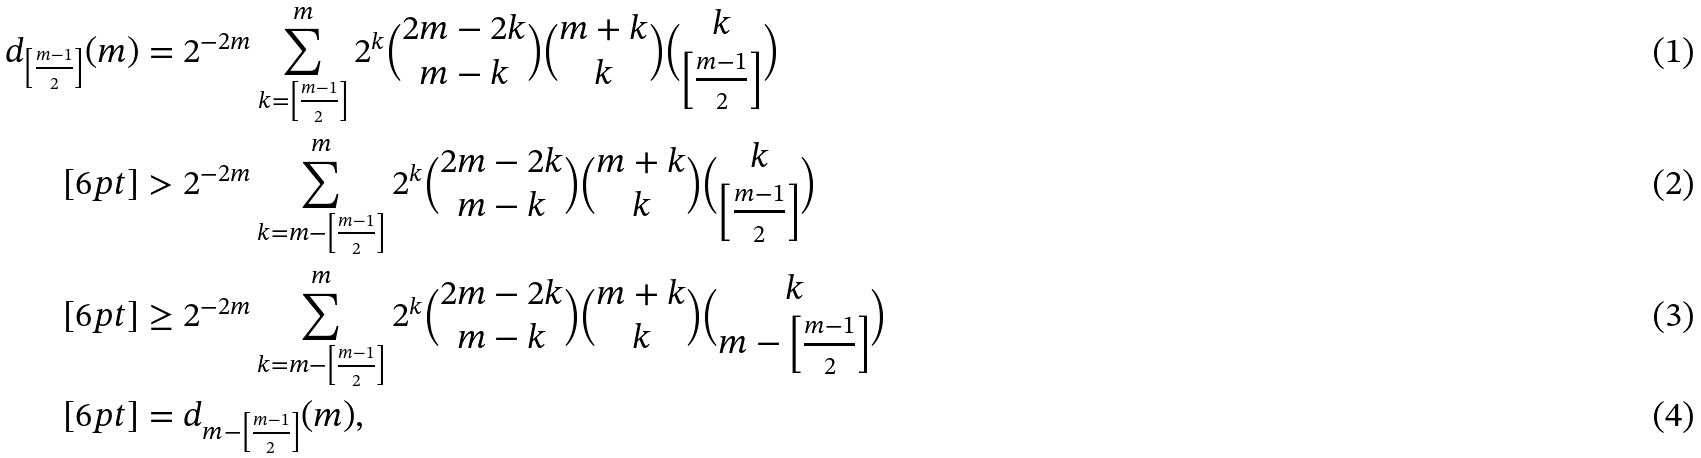<formula> <loc_0><loc_0><loc_500><loc_500>d _ { \left [ \frac { m - 1 } { 2 } \right ] } ( m ) & = 2 ^ { - 2 m } \sum _ { k = \left [ \frac { m - 1 } { 2 } \right ] } ^ { m } 2 ^ { k } { 2 m - 2 k \choose m - k } { m + k \choose k } { k \choose \left [ \frac { m - 1 } { 2 } \right ] } \\ [ 6 p t ] & > 2 ^ { - 2 m } \sum _ { k = m - \left [ \frac { m - 1 } { 2 } \right ] } ^ { m } 2 ^ { k } { 2 m - 2 k \choose m - k } { m + k \choose k } { k \choose \left [ \frac { m - 1 } { 2 } \right ] } \\ [ 6 p t ] & \geq 2 ^ { - 2 m } \sum _ { k = m - \left [ \frac { m - 1 } { 2 } \right ] } ^ { m } 2 ^ { k } { 2 m - 2 k \choose m - k } { m + k \choose k } { k \choose m - \left [ \frac { m - 1 } { 2 } \right ] } \\ [ 6 p t ] & = d _ { m - \left [ \frac { m - 1 } { 2 } \right ] } ( m ) ,</formula> 